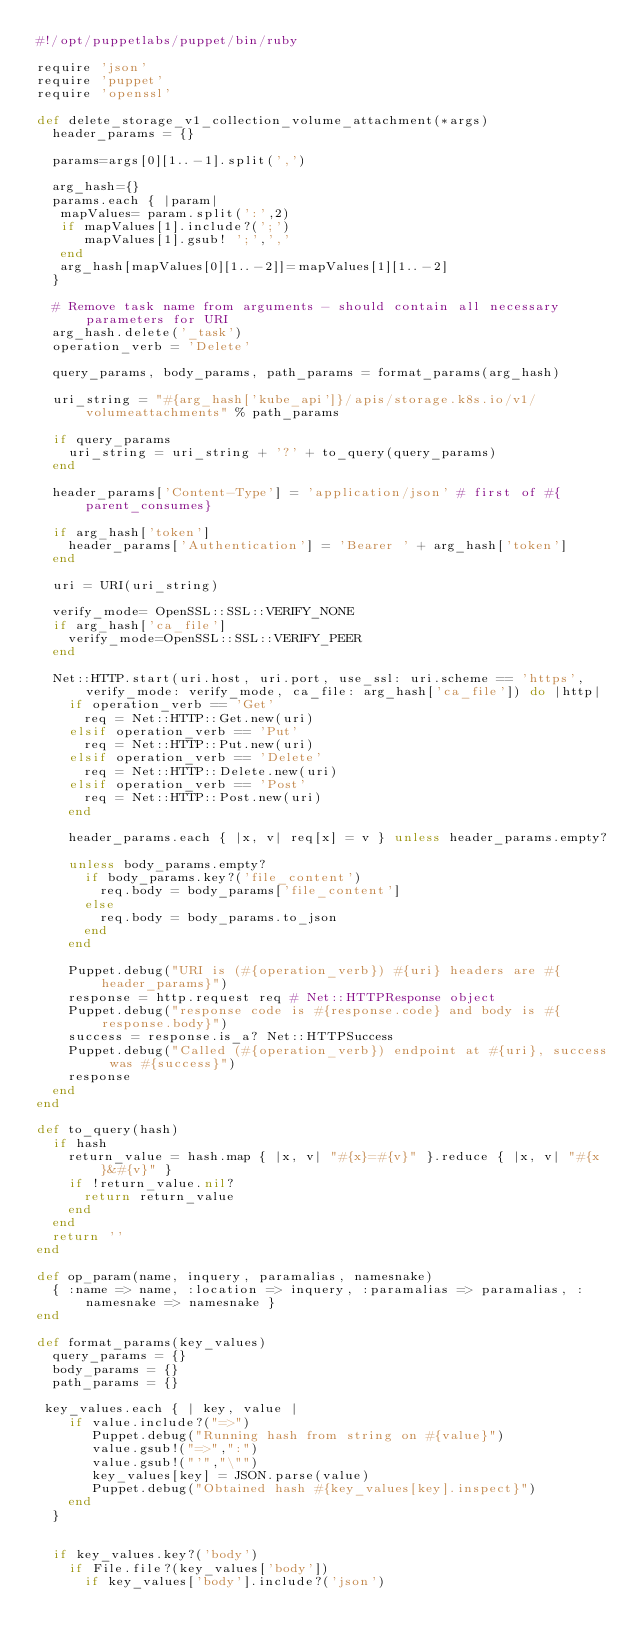Convert code to text. <code><loc_0><loc_0><loc_500><loc_500><_Ruby_>#!/opt/puppetlabs/puppet/bin/ruby

require 'json'
require 'puppet'
require 'openssl'

def delete_storage_v1_collection_volume_attachment(*args)
  header_params = {}
  
  params=args[0][1..-1].split(',')

  arg_hash={}
  params.each { |param|
   mapValues= param.split(':',2)
   if mapValues[1].include?(';')
      mapValues[1].gsub! ';',','
   end
   arg_hash[mapValues[0][1..-2]]=mapValues[1][1..-2]
  }

  # Remove task name from arguments - should contain all necessary parameters for URI
  arg_hash.delete('_task')
  operation_verb = 'Delete'

  query_params, body_params, path_params = format_params(arg_hash)

  uri_string = "#{arg_hash['kube_api']}/apis/storage.k8s.io/v1/volumeattachments" % path_params

  if query_params
    uri_string = uri_string + '?' + to_query(query_params)
  end

  header_params['Content-Type'] = 'application/json' # first of #{parent_consumes}

  if arg_hash['token']
    header_params['Authentication'] = 'Bearer ' + arg_hash['token']
  end

  uri = URI(uri_string)
 
  verify_mode= OpenSSL::SSL::VERIFY_NONE
  if arg_hash['ca_file']
    verify_mode=OpenSSL::SSL::VERIFY_PEER
  end

  Net::HTTP.start(uri.host, uri.port, use_ssl: uri.scheme == 'https', verify_mode: verify_mode, ca_file: arg_hash['ca_file']) do |http|
    if operation_verb == 'Get'
      req = Net::HTTP::Get.new(uri)
    elsif operation_verb == 'Put'
      req = Net::HTTP::Put.new(uri)
    elsif operation_verb == 'Delete'
      req = Net::HTTP::Delete.new(uri)
    elsif operation_verb == 'Post'
      req = Net::HTTP::Post.new(uri)
    end

    header_params.each { |x, v| req[x] = v } unless header_params.empty?

    unless body_params.empty?
      if body_params.key?('file_content')
        req.body = body_params['file_content']
      else
        req.body = body_params.to_json
      end
    end

    Puppet.debug("URI is (#{operation_verb}) #{uri} headers are #{header_params}")
    response = http.request req # Net::HTTPResponse object
    Puppet.debug("response code is #{response.code} and body is #{response.body}")
    success = response.is_a? Net::HTTPSuccess
    Puppet.debug("Called (#{operation_verb}) endpoint at #{uri}, success was #{success}")
    response
  end
end

def to_query(hash)
  if hash
    return_value = hash.map { |x, v| "#{x}=#{v}" }.reduce { |x, v| "#{x}&#{v}" }
    if !return_value.nil?
      return return_value
    end
  end
  return ''
end

def op_param(name, inquery, paramalias, namesnake)
  { :name => name, :location => inquery, :paramalias => paramalias, :namesnake => namesnake }
end

def format_params(key_values)
  query_params = {}
  body_params = {}
  path_params = {}

 key_values.each { | key, value |
    if value.include?("=>")
       Puppet.debug("Running hash from string on #{value}")
       value.gsub!("=>",":")
       value.gsub!("'","\"")
       key_values[key] = JSON.parse(value)
       Puppet.debug("Obtained hash #{key_values[key].inspect}")
    end
  }


  if key_values.key?('body')
    if File.file?(key_values['body'])
      if key_values['body'].include?('json')</code> 